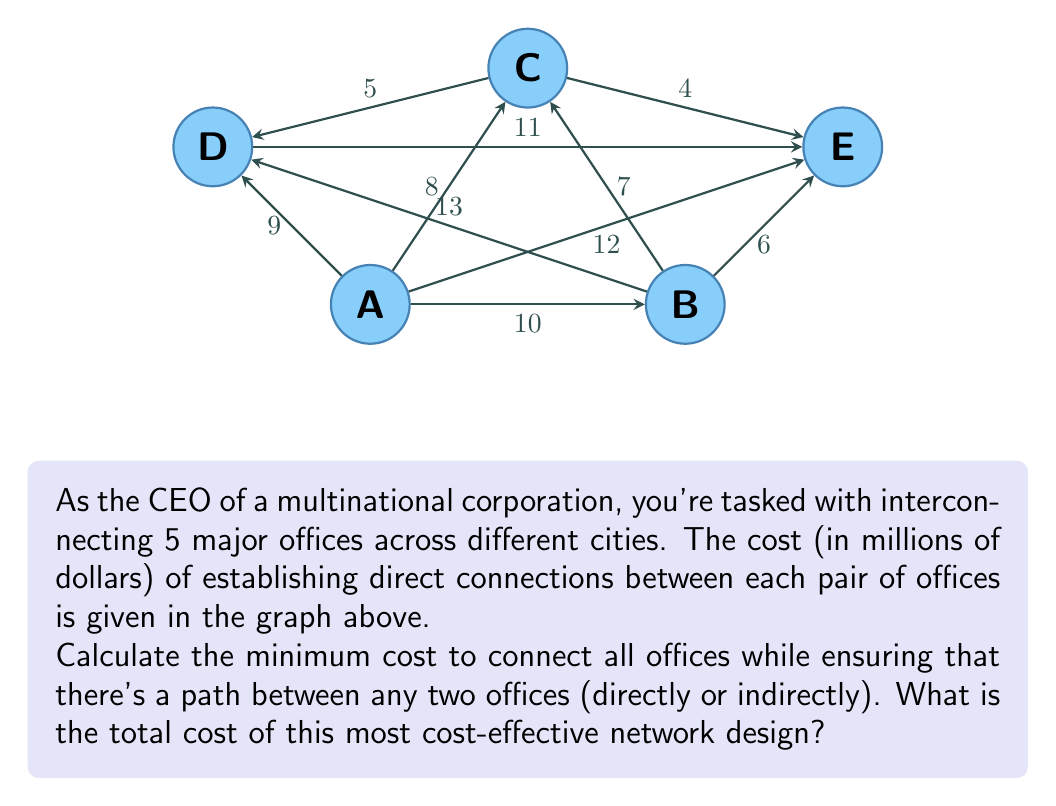What is the answer to this math problem? To solve this problem, we need to find the Minimum Spanning Tree (MST) of the given graph. The MST is a subset of the edges that connects all vertices together with the minimum total edge weight. We'll use Kruskal's algorithm to find the MST:

1) Sort all edges by weight in ascending order:
   $$(C,E): 4, (C,D): 5, (B,E): 6, (B,C): 7, (A,C): 8, (A,D): 9, (A,B): 10, (D,E): 11, (A,E): 12, (B,D): 13$$

2) Start with an empty set of edges and add edges one by one, skipping any that would create a cycle:

   - Add (C,E): 4
   - Add (C,D): 5
   - Add (B,E): 6
   - Add (B,C): 7
   - Add (A,C): 8

3) At this point, we have added 5 edges, which is sufficient to connect all 5 vertices (offices). We stop here as adding any more edges would create cycles.

4) The MST consists of these edges: (C,E), (C,D), (B,E), (B,C), and (A,C).

5) Calculate the total cost by summing the weights of these edges:
   $$4 + 5 + 6 + 7 + 8 = 30$$

Therefore, the minimum cost to connect all offices while ensuring a path between any two offices is 30 million dollars.
Answer: $30 million 